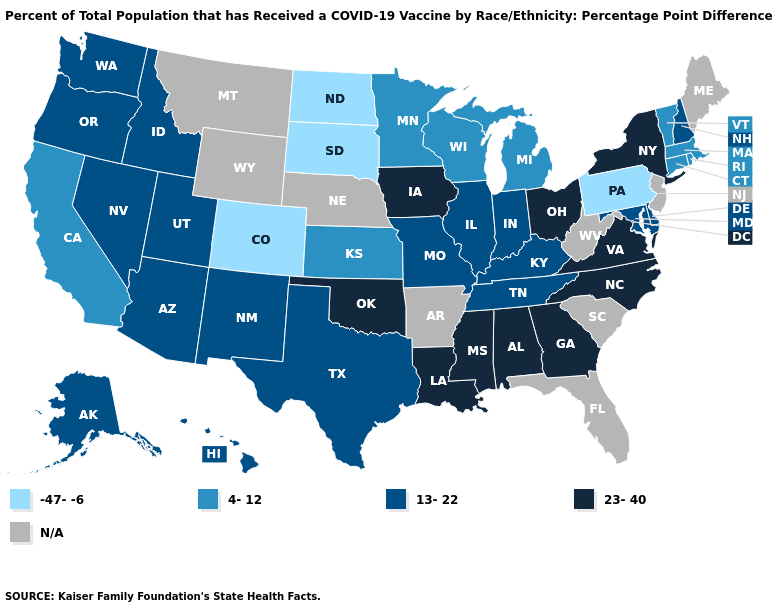Does the map have missing data?
Answer briefly. Yes. Name the states that have a value in the range 23-40?
Answer briefly. Alabama, Georgia, Iowa, Louisiana, Mississippi, New York, North Carolina, Ohio, Oklahoma, Virginia. Does Massachusetts have the highest value in the USA?
Keep it brief. No. Does the first symbol in the legend represent the smallest category?
Write a very short answer. Yes. Name the states that have a value in the range 23-40?
Short answer required. Alabama, Georgia, Iowa, Louisiana, Mississippi, New York, North Carolina, Ohio, Oklahoma, Virginia. What is the value of Maine?
Answer briefly. N/A. What is the highest value in states that border Iowa?
Give a very brief answer. 13-22. Name the states that have a value in the range N/A?
Keep it brief. Arkansas, Florida, Maine, Montana, Nebraska, New Jersey, South Carolina, West Virginia, Wyoming. Which states hav the highest value in the West?
Give a very brief answer. Alaska, Arizona, Hawaii, Idaho, Nevada, New Mexico, Oregon, Utah, Washington. Does Pennsylvania have the lowest value in the USA?
Be succinct. Yes. Among the states that border Nevada , does California have the highest value?
Quick response, please. No. What is the value of Iowa?
Be succinct. 23-40. Among the states that border Nevada , does Idaho have the highest value?
Give a very brief answer. Yes. 